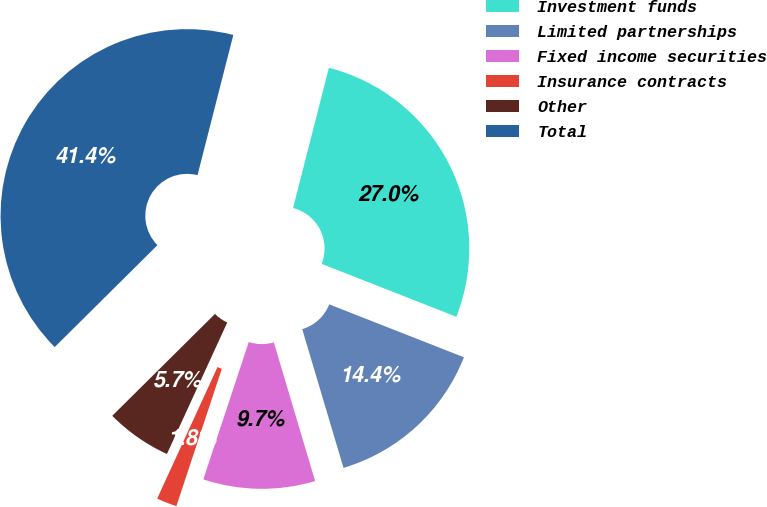<chart> <loc_0><loc_0><loc_500><loc_500><pie_chart><fcel>Investment funds<fcel>Limited partnerships<fcel>Fixed income securities<fcel>Insurance contracts<fcel>Other<fcel>Total<nl><fcel>26.98%<fcel>14.44%<fcel>9.69%<fcel>1.76%<fcel>5.72%<fcel>41.42%<nl></chart> 